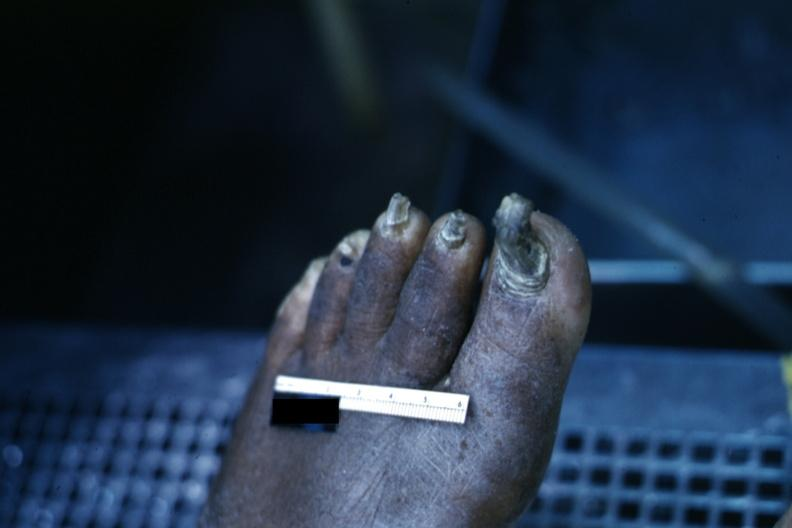s foot present?
Answer the question using a single word or phrase. Yes 